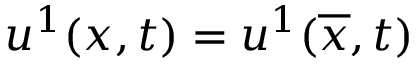Convert formula to latex. <formula><loc_0><loc_0><loc_500><loc_500>u ^ { 1 } ( x , t ) = u ^ { 1 } ( \overline { x } , t )</formula> 